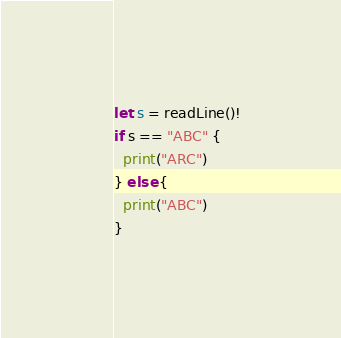<code> <loc_0><loc_0><loc_500><loc_500><_Swift_>let s = readLine()!
if s == "ABC" {
  print("ARC")
} else {
  print("ABC")
}</code> 